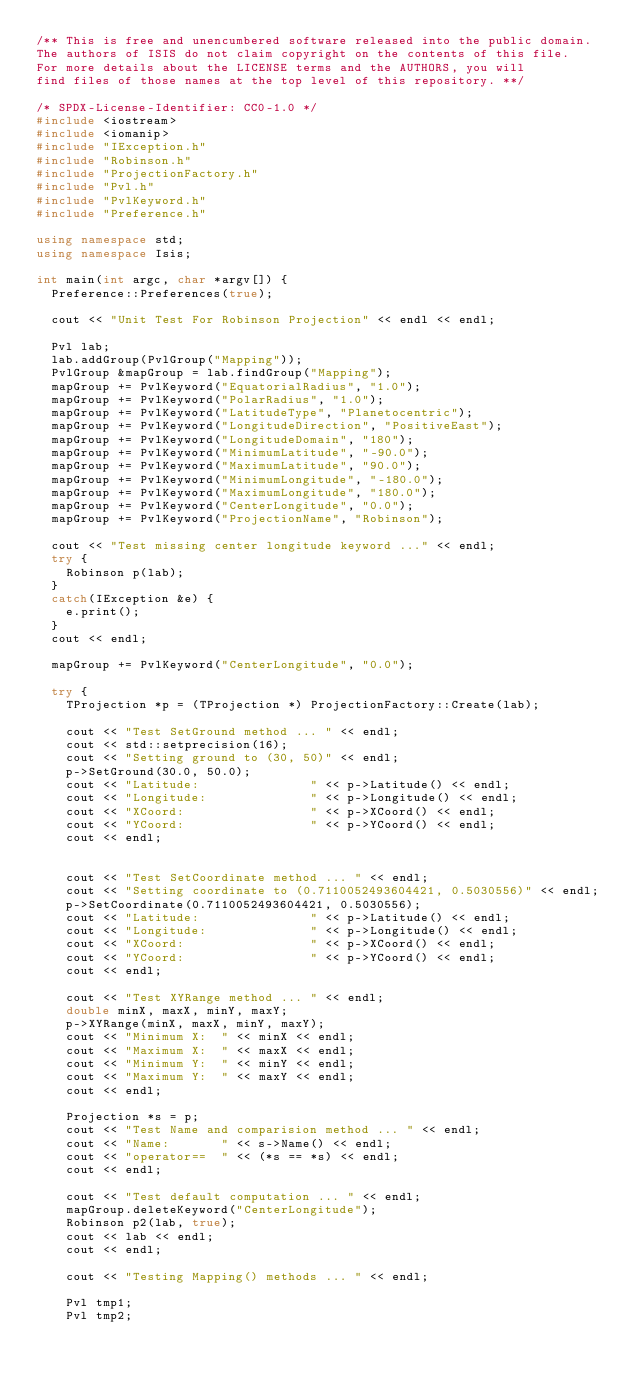Convert code to text. <code><loc_0><loc_0><loc_500><loc_500><_C++_>/** This is free and unencumbered software released into the public domain.
The authors of ISIS do not claim copyright on the contents of this file.
For more details about the LICENSE terms and the AUTHORS, you will
find files of those names at the top level of this repository. **/

/* SPDX-License-Identifier: CC0-1.0 */
#include <iostream>
#include <iomanip>
#include "IException.h"
#include "Robinson.h"
#include "ProjectionFactory.h"
#include "Pvl.h"
#include "PvlKeyword.h"
#include "Preference.h"

using namespace std;
using namespace Isis;

int main(int argc, char *argv[]) {
  Preference::Preferences(true);

  cout << "Unit Test For Robinson Projection" << endl << endl;

  Pvl lab;
  lab.addGroup(PvlGroup("Mapping"));
  PvlGroup &mapGroup = lab.findGroup("Mapping");
  mapGroup += PvlKeyword("EquatorialRadius", "1.0");
  mapGroup += PvlKeyword("PolarRadius", "1.0");
  mapGroup += PvlKeyword("LatitudeType", "Planetocentric");
  mapGroup += PvlKeyword("LongitudeDirection", "PositiveEast");
  mapGroup += PvlKeyword("LongitudeDomain", "180");
  mapGroup += PvlKeyword("MinimumLatitude", "-90.0");
  mapGroup += PvlKeyword("MaximumLatitude", "90.0");
  mapGroup += PvlKeyword("MinimumLongitude", "-180.0");
  mapGroup += PvlKeyword("MaximumLongitude", "180.0");
  mapGroup += PvlKeyword("CenterLongitude", "0.0");
  mapGroup += PvlKeyword("ProjectionName", "Robinson");

  cout << "Test missing center longitude keyword ..." << endl;
  try {
    Robinson p(lab);
  }
  catch(IException &e) {
    e.print();
  }
  cout << endl;

  mapGroup += PvlKeyword("CenterLongitude", "0.0");

  try {
    TProjection *p = (TProjection *) ProjectionFactory::Create(lab);

    cout << "Test SetGround method ... " << endl;
    cout << std::setprecision(16);
    cout << "Setting ground to (30, 50)" << endl;
    p->SetGround(30.0, 50.0);
    cout << "Latitude:               " << p->Latitude() << endl;
    cout << "Longitude:              " << p->Longitude() << endl;
    cout << "XCoord:                 " << p->XCoord() << endl;
    cout << "YCoord:                 " << p->YCoord() << endl;
    cout << endl;


    cout << "Test SetCoordinate method ... " << endl;
    cout << "Setting coordinate to (0.7110052493604421, 0.5030556)" << endl;
    p->SetCoordinate(0.7110052493604421, 0.5030556);
    cout << "Latitude:               " << p->Latitude() << endl;
    cout << "Longitude:              " << p->Longitude() << endl;
    cout << "XCoord:                 " << p->XCoord() << endl;
    cout << "YCoord:                 " << p->YCoord() << endl;
    cout << endl;

    cout << "Test XYRange method ... " << endl;
    double minX, maxX, minY, maxY;
    p->XYRange(minX, maxX, minY, maxY);
    cout << "Minimum X:  " << minX << endl;
    cout << "Maximum X:  " << maxX << endl;
    cout << "Minimum Y:  " << minY << endl;
    cout << "Maximum Y:  " << maxY << endl;
    cout << endl;

    Projection *s = p;
    cout << "Test Name and comparision method ... " << endl;
    cout << "Name:       " << s->Name() << endl;
    cout << "operator==  " << (*s == *s) << endl;
    cout << endl;

    cout << "Test default computation ... " << endl;
    mapGroup.deleteKeyword("CenterLongitude");
    Robinson p2(lab, true);
    cout << lab << endl;
    cout << endl;

    cout << "Testing Mapping() methods ... " << endl;

    Pvl tmp1;
    Pvl tmp2;</code> 